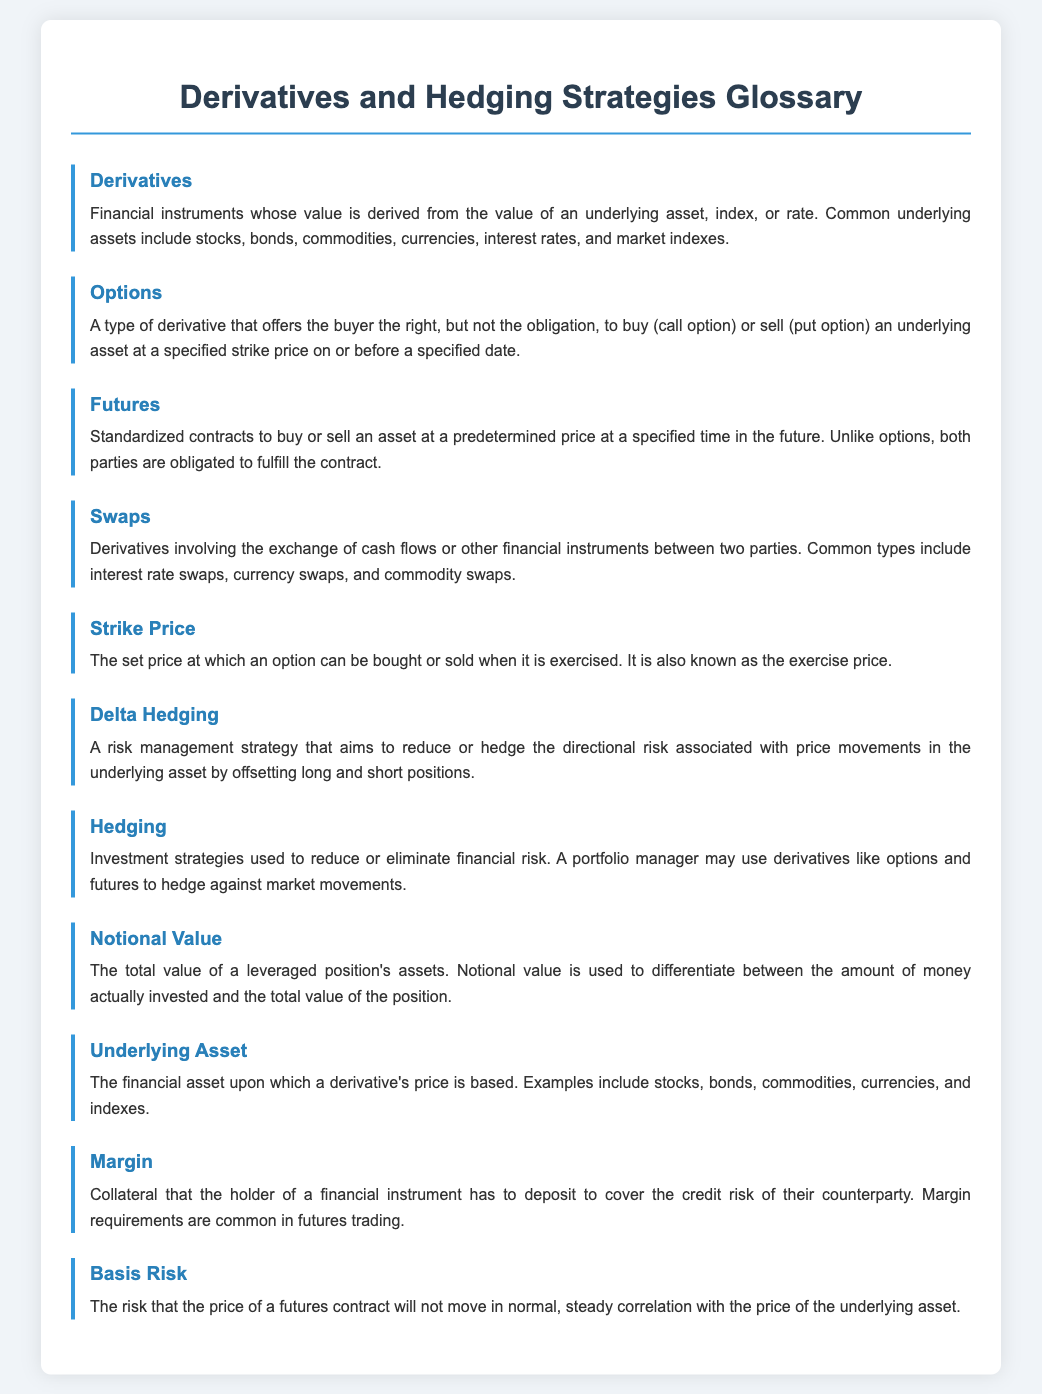What are derivatives? Derivatives are defined in the document as financial instruments whose value is derived from the value of an underlying asset, index, or rate.
Answer: Financial instruments What is the definition of options? The document specifies that options are a type of derivative that offers the buyer the right, but not the obligation, to buy or sell an underlying asset.
Answer: Right to buy or sell What is the term for the obligation to buy or sell an asset in future contracts? The term used in the document for standardized contracts that obligate both parties to fulfill is futures.
Answer: Futures What are swaps? According to the document, swaps are derivatives involving the exchange of cash flows or other financial instruments between two parties.
Answer: Exchange of cash flows What is the strike price? The document states that the strike price is the set price at which an option can be bought or sold when it is exercised.
Answer: Set price What does delta hedging aim to do? The document explains that delta hedging aims to reduce or hedge the directional risk associated with price movements in the underlying asset.
Answer: Reduce directional risk What is the purpose of hedging? The document mentions that hedging is used to reduce or eliminate financial risk.
Answer: Reduce financial risk What is meant by notional value? The document describes notional value as the total value of a leveraged position's assets.
Answer: Total value of assets What does margin refer to in trading? The document defines margin as collateral that the holder of a financial instrument has to deposit to cover the credit risk of their counterparty.
Answer: Collateral deposit What is basis risk? According to the document, basis risk is the risk that the price of a futures contract will not move in normal correlation with the price of the underlying asset.
Answer: Risk of price movement 